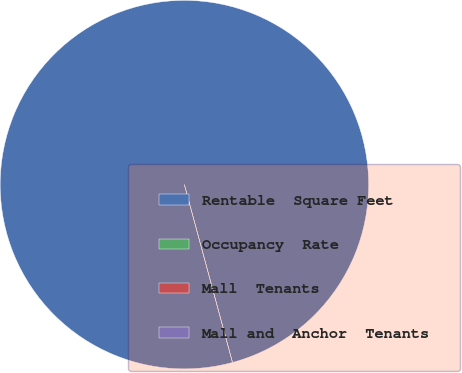Convert chart to OTSL. <chart><loc_0><loc_0><loc_500><loc_500><pie_chart><fcel>Rentable  Square Feet<fcel>Occupancy  Rate<fcel>Mall  Tenants<fcel>Mall and  Anchor  Tenants<nl><fcel>100.0%<fcel>0.0%<fcel>0.0%<fcel>0.0%<nl></chart> 